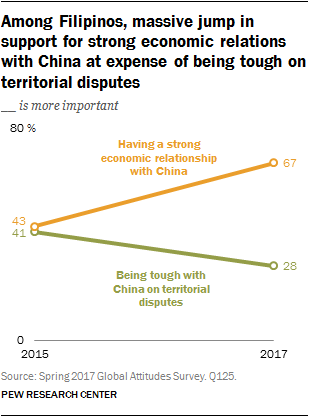Draw attention to some important aspects in this diagram. In 2015 and 2017, the ratio of the difference between the green and orange graph was 0.0513... The value of green was not 67 in 2017. 